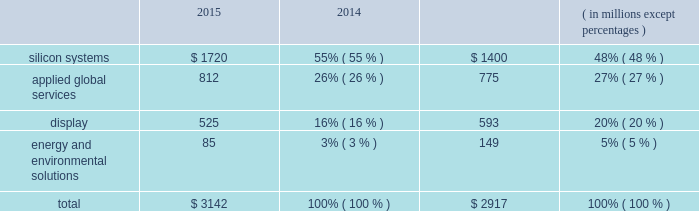Backlog applied manufactures systems to meet demand represented by order backlog and customer commitments .
Backlog consists of : ( 1 ) orders for which written authorizations have been accepted and assigned shipment dates are within the next 12 months , or shipment has occurred but revenue has not been recognized ; and ( 2 ) contractual service revenue and maintenance fees to be earned within the next 12 months .
Backlog by reportable segment as of october 25 , 2015 and october 26 , 2014 was as follows : 2015 2014 ( in millions , except percentages ) .
Applied 2019s backlog on any particular date is not necessarily indicative of actual sales for any future periods , due to the potential for customer changes in delivery schedules or order cancellations .
Customers may delay delivery of products or cancel orders prior to shipment , subject to possible cancellation penalties .
Delays in delivery schedules or a reduction of backlog during any particular period could have a material adverse effect on applied 2019s business and results of operations .
Manufacturing , raw materials and supplies applied 2019s manufacturing activities consist primarily of assembly , test and integration of various proprietary and commercial parts , components and subassemblies that are used to manufacture systems .
Applied has implemented a distributed manufacturing model under which manufacturing and supply chain activities are conducted in various countries , including germany , israel , italy , singapore , taiwan , the united states and other countries in asia .
Applied uses numerous vendors , including contract manufacturers , to supply parts and assembly services for the manufacture and support of its products , including some systems being completed at customer sites .
Although applied makes reasonable efforts to assure that parts are available from multiple qualified suppliers , this is not always possible .
Accordingly , some key parts may be obtained from only a single supplier or a limited group of suppliers .
Applied seeks to reduce costs and to lower the risks of manufacturing and service interruptions by selecting and qualifying alternate suppliers for key parts ; monitoring the financial condition of key suppliers ; maintaining appropriate inventories of key parts ; qualifying new parts on a timely basis ; and ensuring quality and performance of parts. .
What is the growth rate in the segment of display from 2014 to 2015? 
Computations: ((525 - 593) / 593)
Answer: -0.11467. 